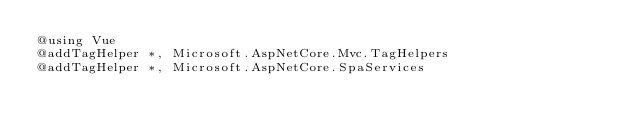Convert code to text. <code><loc_0><loc_0><loc_500><loc_500><_C#_>@using Vue
@addTagHelper *, Microsoft.AspNetCore.Mvc.TagHelpers
@addTagHelper *, Microsoft.AspNetCore.SpaServices
</code> 